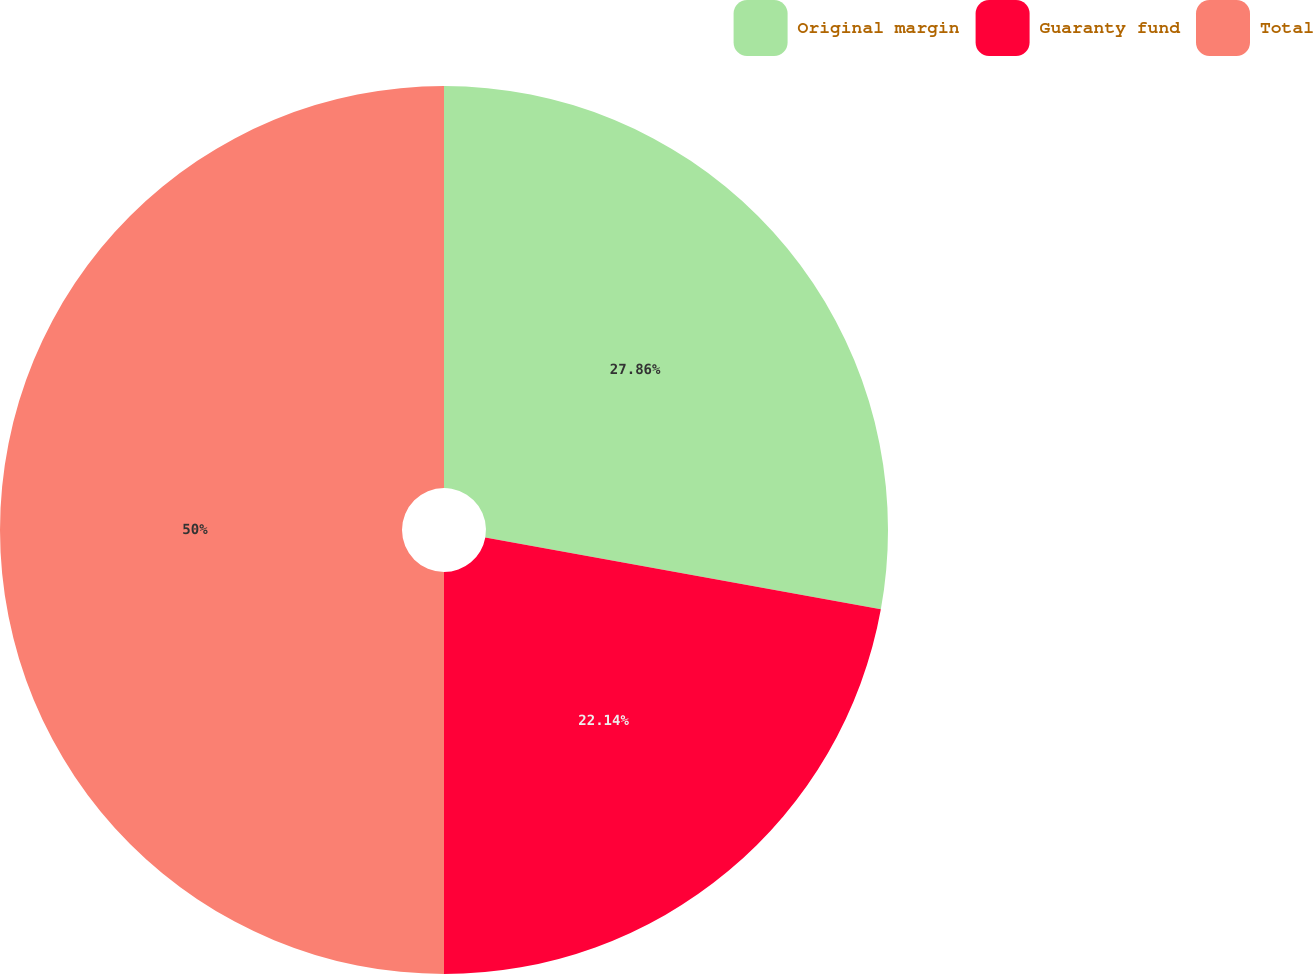Convert chart to OTSL. <chart><loc_0><loc_0><loc_500><loc_500><pie_chart><fcel>Original margin<fcel>Guaranty fund<fcel>Total<nl><fcel>27.86%<fcel>22.14%<fcel>50.0%<nl></chart> 